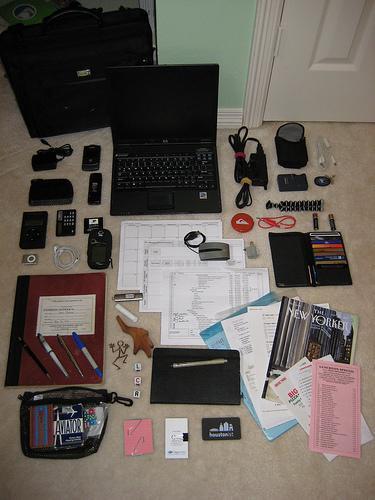How many pens are on the notebook?
Give a very brief answer. 4. How many pamphlets are on top of the magazine?
Give a very brief answer. 3. 